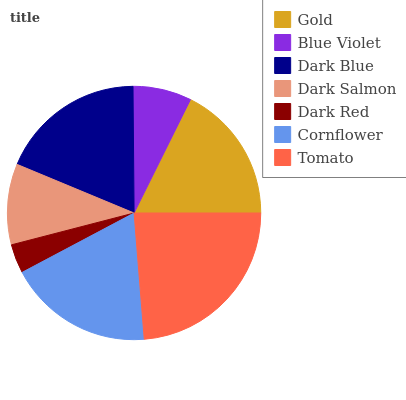Is Dark Red the minimum?
Answer yes or no. Yes. Is Tomato the maximum?
Answer yes or no. Yes. Is Blue Violet the minimum?
Answer yes or no. No. Is Blue Violet the maximum?
Answer yes or no. No. Is Gold greater than Blue Violet?
Answer yes or no. Yes. Is Blue Violet less than Gold?
Answer yes or no. Yes. Is Blue Violet greater than Gold?
Answer yes or no. No. Is Gold less than Blue Violet?
Answer yes or no. No. Is Gold the high median?
Answer yes or no. Yes. Is Gold the low median?
Answer yes or no. Yes. Is Cornflower the high median?
Answer yes or no. No. Is Cornflower the low median?
Answer yes or no. No. 